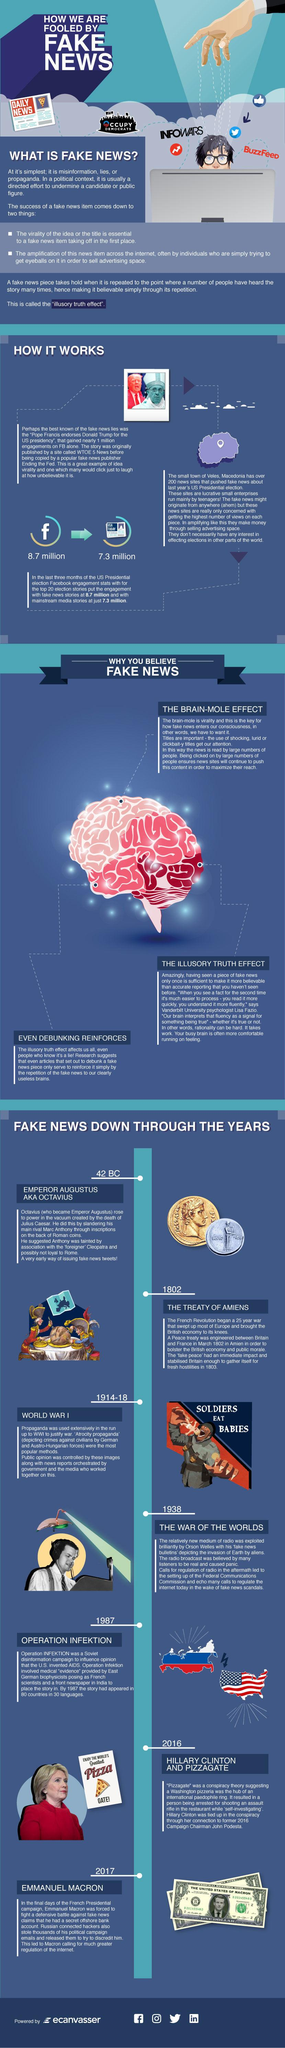List a handful of essential elements in this visual. There are two flags depicted in this infographic. There are two coins depicted in this infographic. 